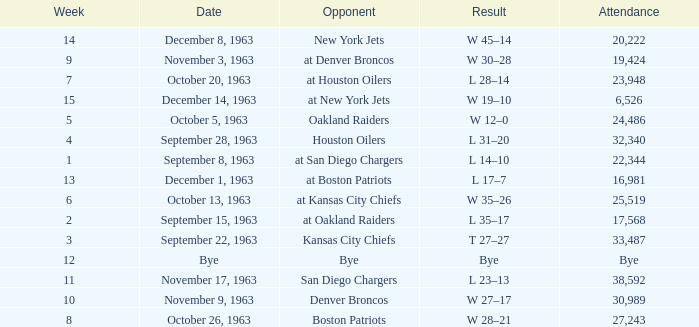Which Opponent has a Result of l 14–10? At san diego chargers. 